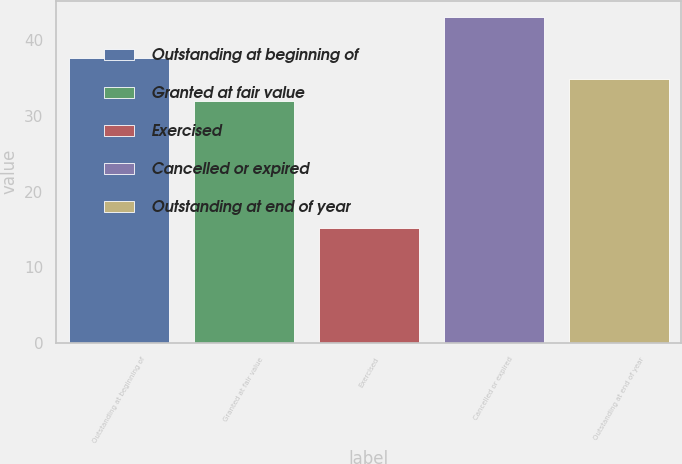Convert chart to OTSL. <chart><loc_0><loc_0><loc_500><loc_500><bar_chart><fcel>Outstanding at beginning of<fcel>Granted at fair value<fcel>Exercised<fcel>Cancelled or expired<fcel>Outstanding at end of year<nl><fcel>37.72<fcel>32.02<fcel>15.16<fcel>43.1<fcel>34.93<nl></chart> 